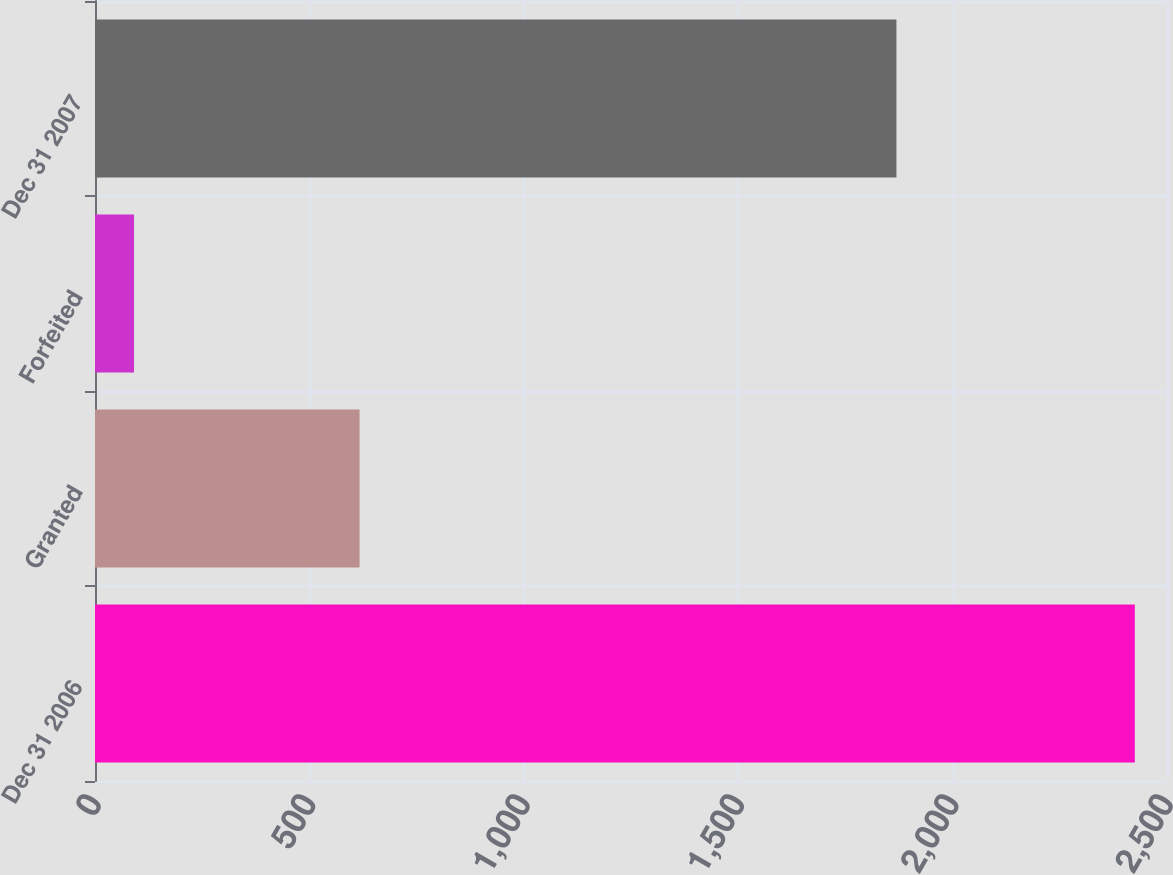Convert chart. <chart><loc_0><loc_0><loc_500><loc_500><bar_chart><fcel>Dec 31 2006<fcel>Granted<fcel>Forfeited<fcel>Dec 31 2007<nl><fcel>2425<fcel>617<fcel>91<fcel>1869<nl></chart> 